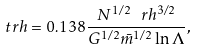Convert formula to latex. <formula><loc_0><loc_0><loc_500><loc_500>\ t r h = 0 . 1 3 8 \frac { N ^ { 1 / 2 } \ r h ^ { 3 / 2 } } { G ^ { 1 / 2 } \bar { m } ^ { 1 / 2 } \ln \Lambda } ,</formula> 